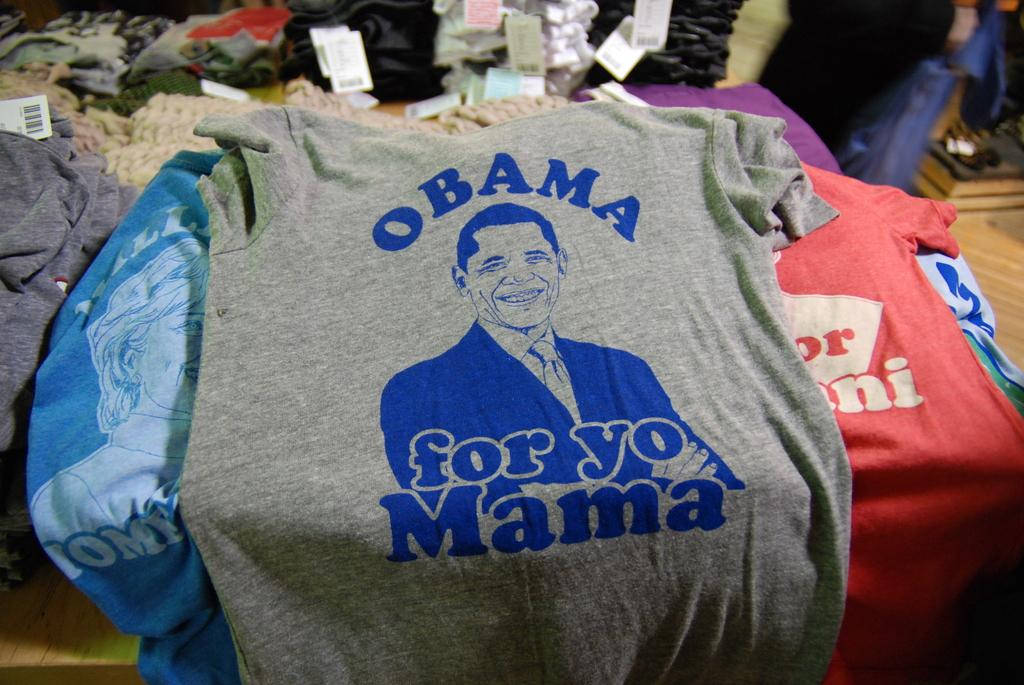<image>
Summarize the visual content of the image. A t shirt saying Obama for yo Mama is on top of a stack of shirts. 